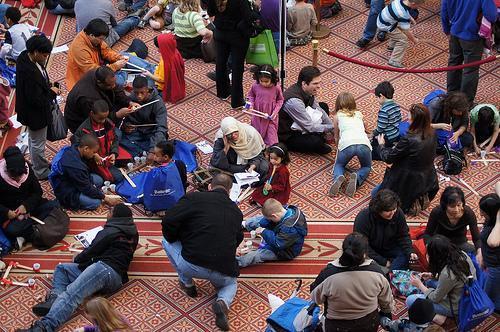How many people are wearing jeans?
Give a very brief answer. 6. How many green bags are in the scene?
Give a very brief answer. 1. How many red ropes are in the photo?
Give a very brief answer. 1. How many striped shirts are in the photo?
Give a very brief answer. 3. How many black coats are in the photo?
Give a very brief answer. 6. 